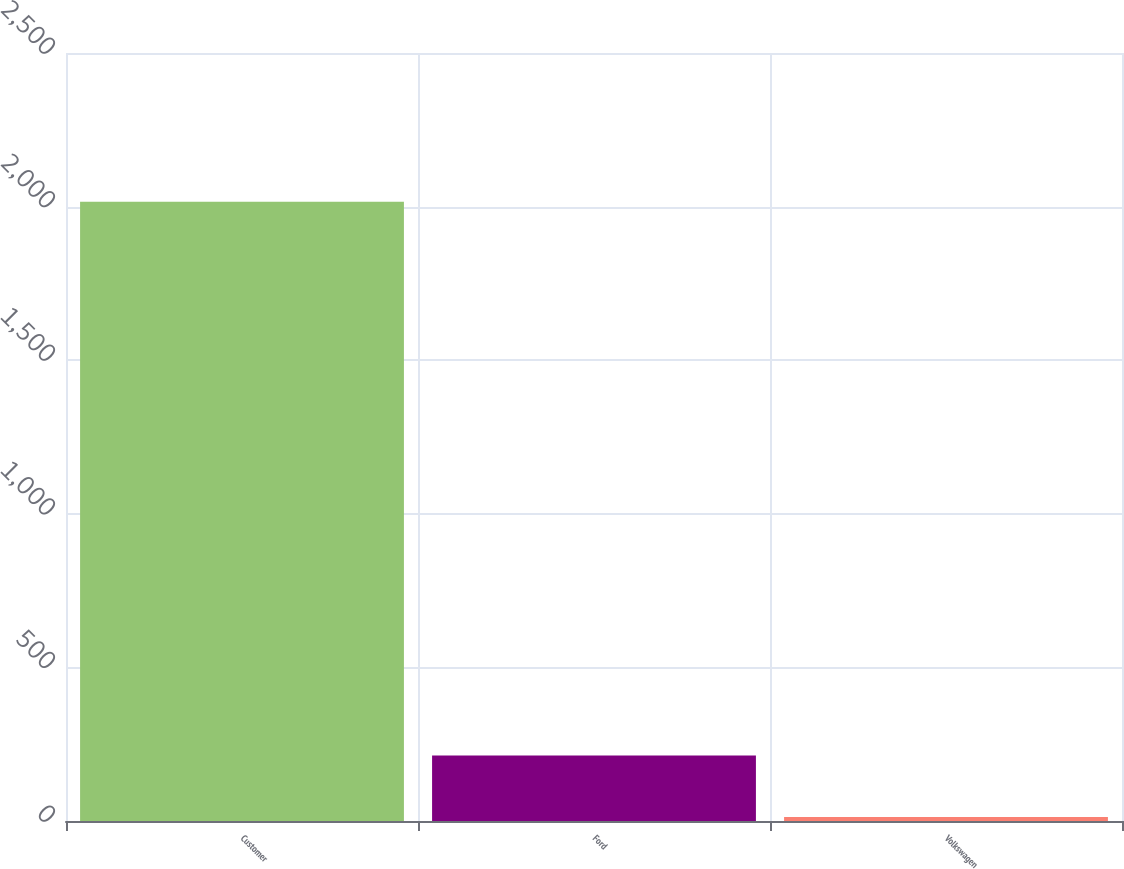Convert chart to OTSL. <chart><loc_0><loc_0><loc_500><loc_500><bar_chart><fcel>Customer<fcel>Ford<fcel>Volkswagen<nl><fcel>2016<fcel>213.3<fcel>13<nl></chart> 